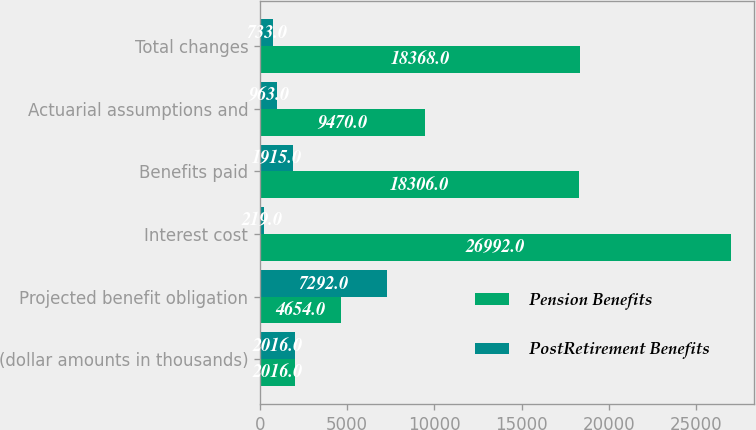<chart> <loc_0><loc_0><loc_500><loc_500><stacked_bar_chart><ecel><fcel>(dollar amounts in thousands)<fcel>Projected benefit obligation<fcel>Interest cost<fcel>Benefits paid<fcel>Actuarial assumptions and<fcel>Total changes<nl><fcel>Pension Benefits<fcel>2016<fcel>4654<fcel>26992<fcel>18306<fcel>9470<fcel>18368<nl><fcel>PostRetirement Benefits<fcel>2016<fcel>7292<fcel>219<fcel>1915<fcel>963<fcel>733<nl></chart> 